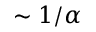<formula> <loc_0><loc_0><loc_500><loc_500>\sim 1 / \alpha</formula> 